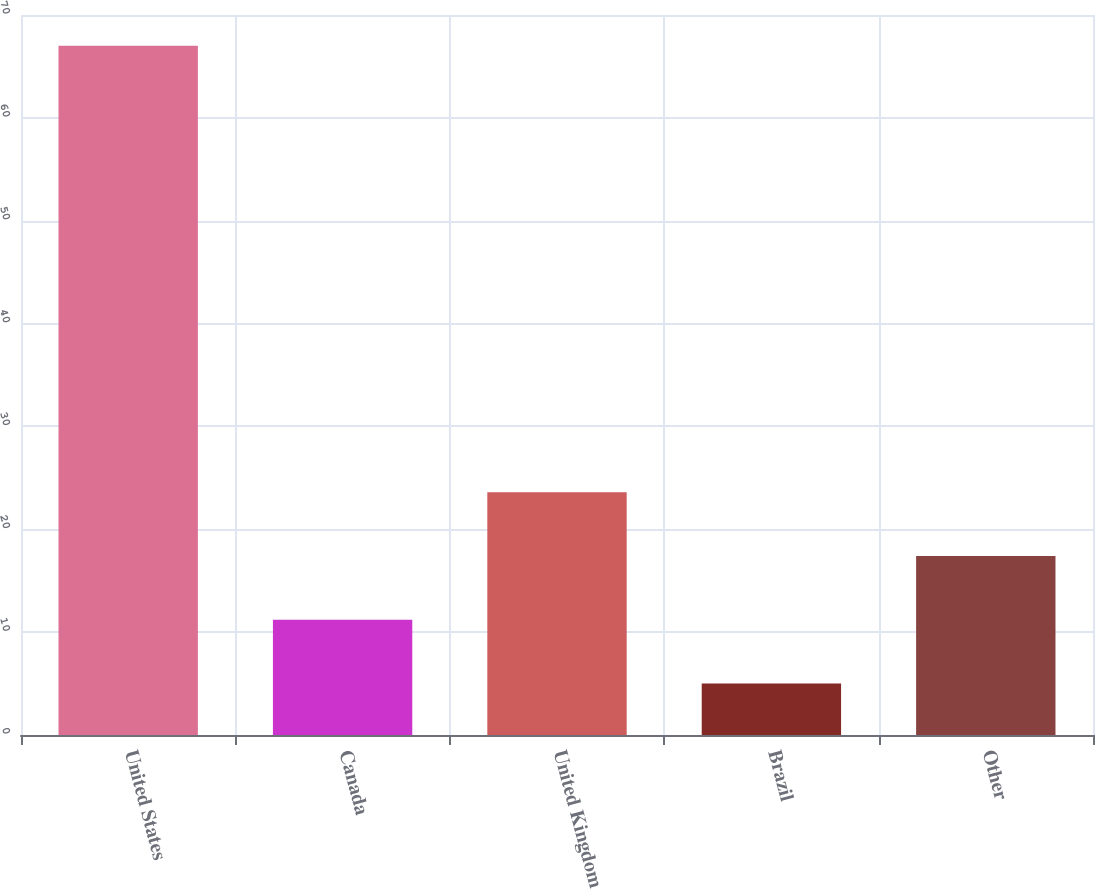Convert chart. <chart><loc_0><loc_0><loc_500><loc_500><bar_chart><fcel>United States<fcel>Canada<fcel>United Kingdom<fcel>Brazil<fcel>Other<nl><fcel>67<fcel>11.2<fcel>23.6<fcel>5<fcel>17.4<nl></chart> 